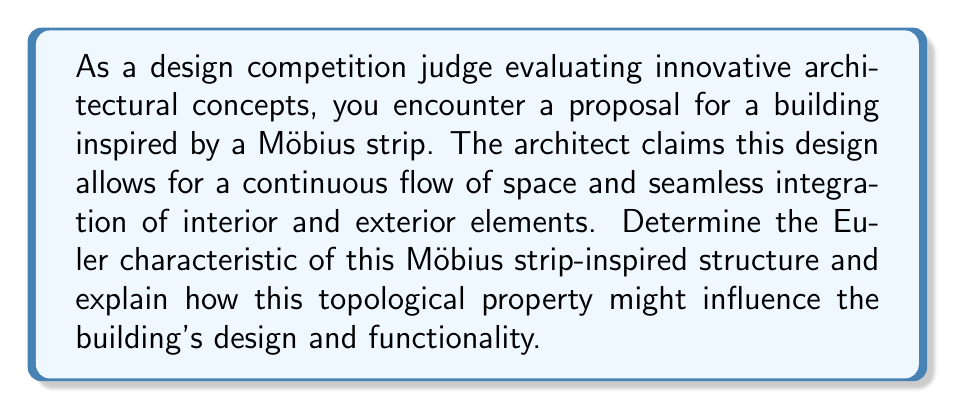Solve this math problem. To solve this problem, we need to understand the topological properties of a Möbius strip and calculate its Euler characteristic. Let's break it down step-by-step:

1. Möbius strip properties:
   - A Möbius strip is a non-orientable surface with only one side and one edge.
   - It can be created by taking a rectangular strip and giving it a half-twist before joining the ends.

2. Triangulation of a Möbius strip:
   To calculate the Euler characteristic, we need to triangulate the surface. A simple triangulation of a Möbius strip can be achieved with:
   - 9 vertices (V)
   - 15 edges (E)
   - 6 faces (F)

3. Calculating the Euler characteristic:
   The Euler characteristic (χ) is defined as:
   
   $$χ = V - E + F$$
   
   Substituting our values:
   
   $$χ = 9 - 15 + 6 = 0$$

4. Implications for design:
   a) Single surface: The Euler characteristic of 0 confirms that the Möbius strip has a single surface, which in architecture could translate to:
      - Seamless transitions between interior and exterior spaces
      - Continuous circulation paths
      - Innovative use of natural light and ventilation

   b) Non-orientability: This property could inspire:
      - Unconventional room layouts and spatial relationships
      - Unique structural challenges and solutions
      - Interesting visual perspectives and optical illusions

   c) Boundary: The single edge of a Möbius strip might influence:
      - The building's façade design
      - Entry and exit points
      - Integration with the surrounding environment

   d) Topological invariance: The Euler characteristic remains unchanged under continuous deformations, suggesting:
      - Flexibility in the final form while maintaining the core concept
      - Potential for adaptive or transformable architectural elements

5. Functionality considerations:
   - Energy efficiency through the continuous surface
   - Innovative approaches to space utilization and programming
   - Potential challenges in traditional building systems integration

By understanding these topological properties, the judge can evaluate how well the architect has leveraged the unique characteristics of a Möbius strip in their design, assessing both the creative concept and its practical implementation in architectural form.
Answer: The Euler characteristic of the Möbius strip-inspired structure is 0. This topological property influences the building's design by enabling seamless interior-exterior transitions, continuous circulation paths, unconventional spatial relationships, and innovative structural solutions, while presenting unique challenges in façade design, entry points, and building systems integration. 